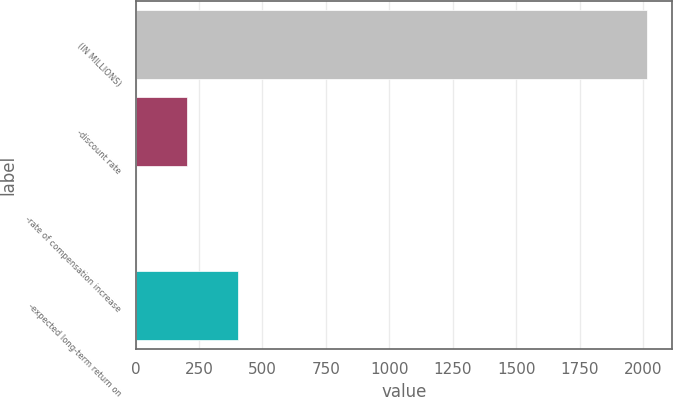<chart> <loc_0><loc_0><loc_500><loc_500><bar_chart><fcel>(IN MILLIONS)<fcel>-discount rate<fcel>-rate of compensation increase<fcel>-expected long-term return on<nl><fcel>2014<fcel>203.2<fcel>2<fcel>404.4<nl></chart> 